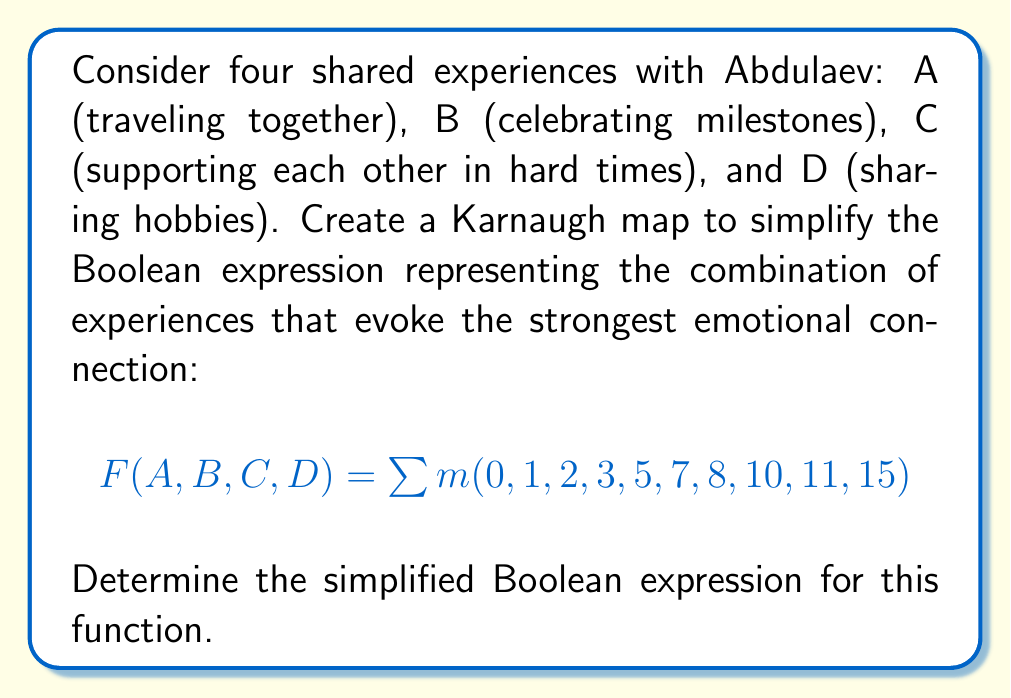Could you help me with this problem? Let's approach this step-by-step:

1) First, we need to create a 4-variable Karnaugh map:

[asy]
unitsize(1cm);
defaultpen(fontsize(10pt));

for(int i=0; i<4; ++i)
  for(int j=0; j<4; ++j)
    draw((i,j)--(i+1,j)--(i+1,j+1)--(i,j+1)--cycle);

label("00", (0.5,-0.5));
label("01", (1.5,-0.5));
label("11", (2.5,-0.5));
label("10", (3.5,-0.5));

label("00", (-0.5,0.5));
label("01", (-0.5,1.5));
label("11", (-0.5,2.5));
label("10", (-0.5,3.5));

label("AB", (-0.5,-0.5));
label("CD", (-1,-0.5));

label("1", (0.5,0.5));
label("1", (1.5,0.5));
label("1", (2.5,0.5));
label("1", (3.5,0.5));
label("1", (0.5,1.5));
label("0", (1.5,1.5));
label("1", (2.5,1.5));
label("0", (3.5,1.5));
label("0", (0.5,2.5));
label("0", (1.5,2.5));
label("1", (2.5,2.5));
label("1", (3.5,2.5));
label("1", (0.5,3.5));
label("0", (1.5,3.5));
label("0", (2.5,3.5));
label("0", (3.5,3.5));
[/asy]

2) Now, we need to identify the largest possible groups of 1's:
   - There's a group of 4 in the first row: $\overline{C}\overline{D}$
   - There's a group of 4 in the first column: $\overline{A}\overline{B}$
   - There's a group of 2 in the third column, third and fourth rows: $AB\overline{C}$

3) The simplified expression is the OR of these terms:

   $F(A,B,C,D) = \overline{C}\overline{D} + \overline{A}\overline{B} + AB\overline{C}$

4) This can be further simplified:
   $F(A,B,C,D) = \overline{C}(\overline{D} + AB) + \overline{A}\overline{B}$

This simplified expression represents the combination of shared experiences that evoke the strongest emotional connection with Abdulaev.
Answer: $$F(A,B,C,D) = \overline{C}(\overline{D} + AB) + \overline{A}\overline{B}$$ 